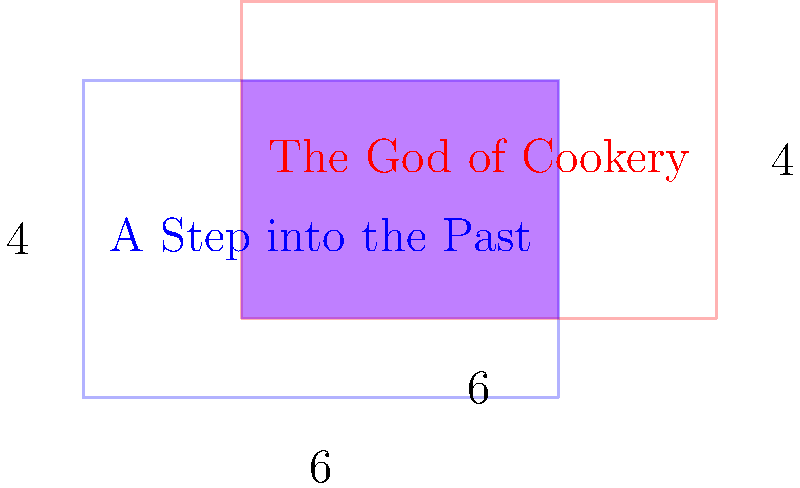In a tribute to classic Hong Kong cinema, two film reels are represented by rectangles on a coordinate plane. The blue rectangle, representing "A Step into the Past", has its bottom-left corner at (0,0) and top-right corner at (6,4). The red rectangle, representing "The God of Cookery", has its bottom-left corner at (2,1) and top-right corner at (8,5). What is the area of the overlapping region between these two iconic films? To find the area of the overlapping region, we need to:

1) Identify the coordinates of the overlapping rectangle:
   - Bottom-left corner: (2,1) (the rightmost of the left sides and the highest of the bottom sides)
   - Top-right corner: (6,4) (the leftmost of the right sides and the lowest of the top sides)

2) Calculate the width of the overlapping rectangle:
   $width = 6 - 2 = 4$

3) Calculate the height of the overlapping rectangle:
   $height = 4 - 1 = 3$

4) Calculate the area of the overlapping rectangle:
   $area = width \times height = 4 \times 3 = 12$

Therefore, the area of the overlapping region is 12 square units.
Answer: 12 square units 